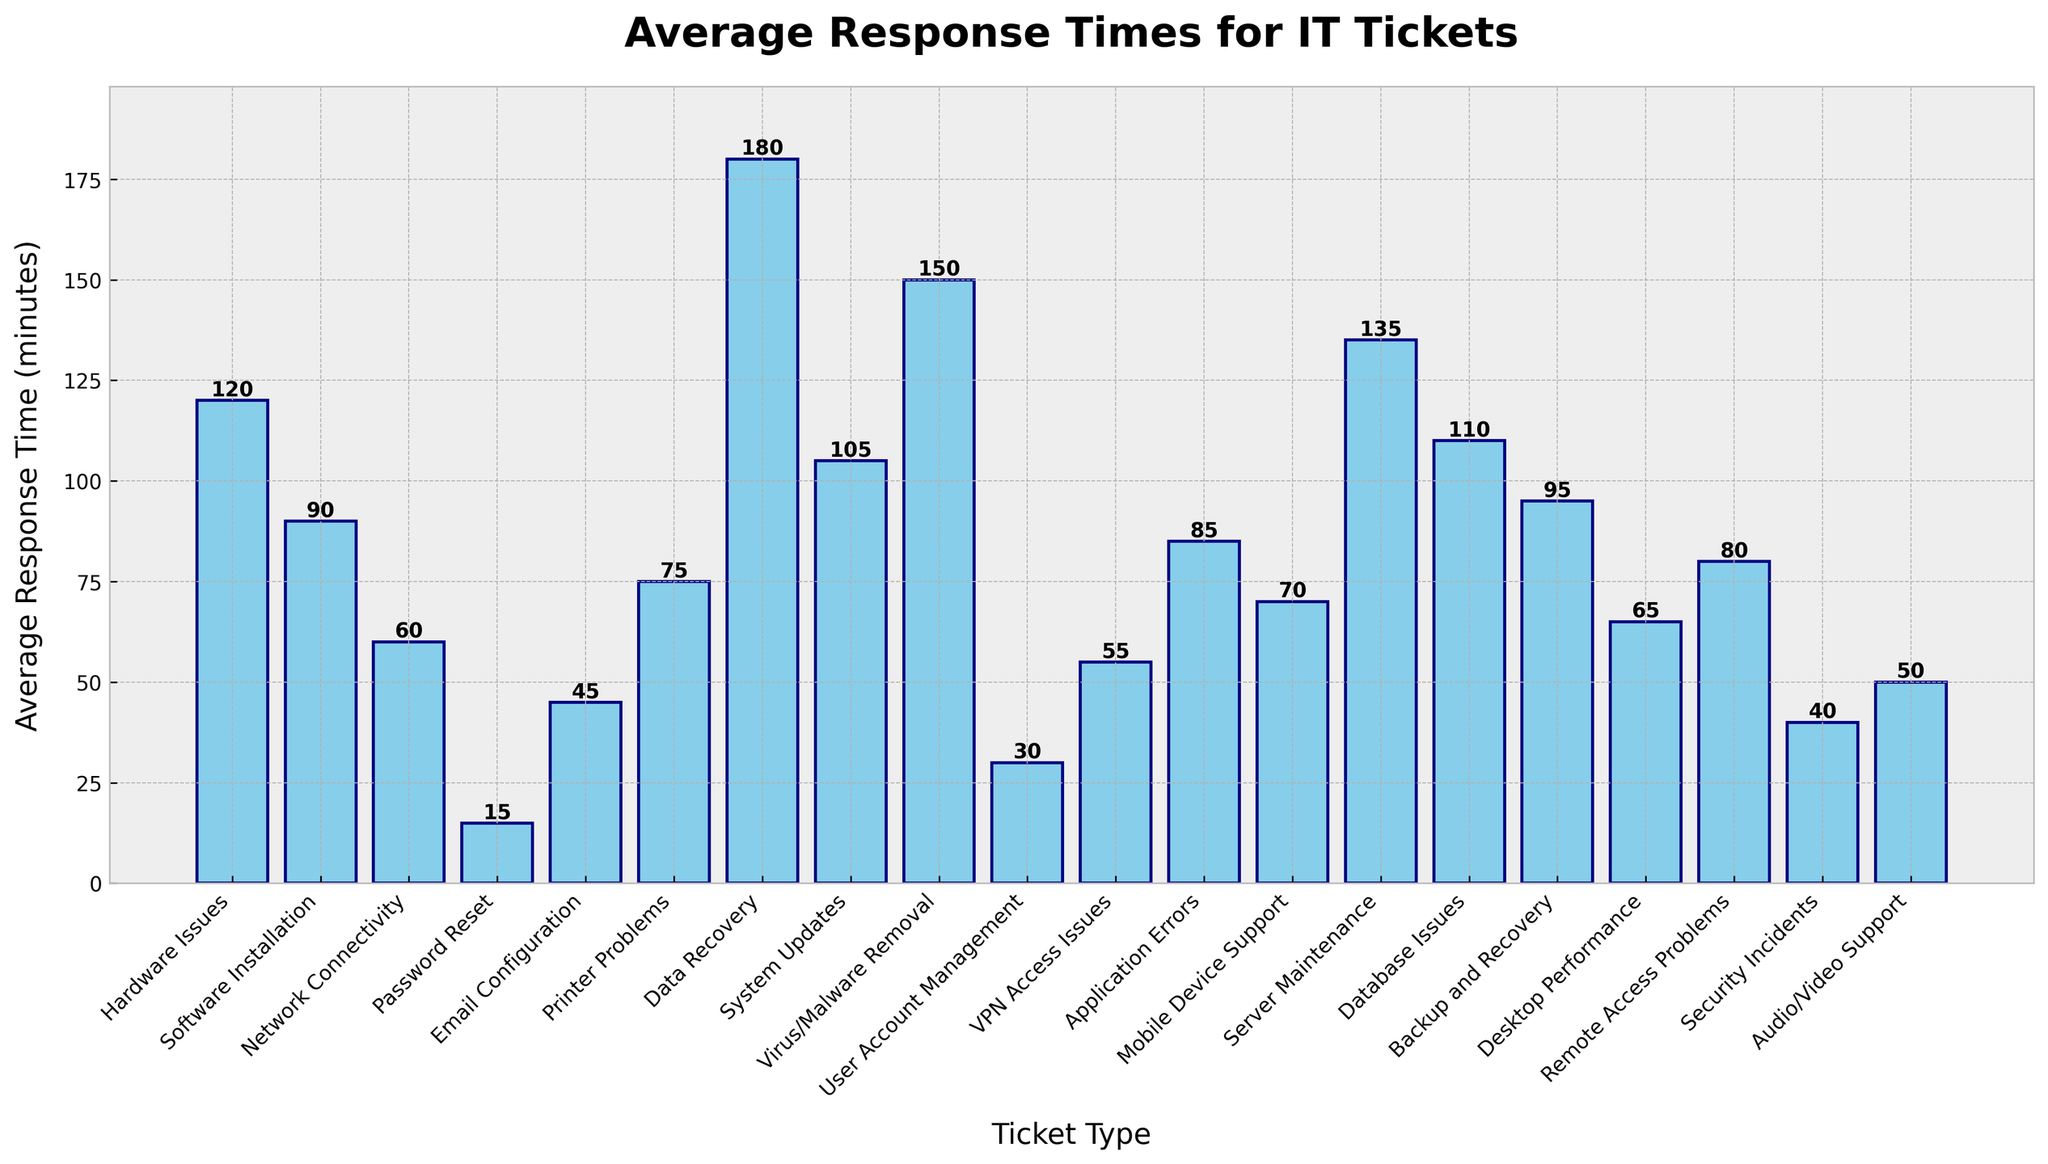Which ticket type has the longest average response time? The bar for 'Data Recovery' is the highest among all types shown on the bar chart.
Answer: Data Recovery Which ticket type has the shortest average response time? The bar for 'Password Reset' is the shortest among all types shown on the bar chart.
Answer: Password Reset How much longer is the average response time for 'Virus/Malware Removal' compared to 'Email Configuration'? 'Virus/Malware Removal' has an average response time of 150 minutes, and 'Email Configuration' has 45 minutes. The difference is 150 - 45 = 105 minutes.
Answer: 105 minutes What's the average of the response times for 'Network Connectivity', 'Password Reset', and 'Email Configuration'? The response times are 60, 15, and 45 minutes respectively. The average is (60 + 15 + 45) / 3 = 120 / 3 = 40 minutes.
Answer: 40 minutes Arrange 'Server Maintenance', 'Database Issues', and 'System Updates' in descending order of their average response times. The average response times are 135, 110, and 105 minutes respectively. Arranging them in descending order gives: 135, 110, 105.
Answer: Server Maintenance, Database Issues, System Updates Which ticket type has an average response time closest to 'Desktop Performance'? 'Desktop Performance' has an average response time of 65 minutes. 'Remote Access Problems' has a response time of 80 minutes, and 'VPN Access Issues' has a response time of 55 minutes. The closest is 'VPN Access Issues' which is 10 minutes away from 65 compared to 'Remote Access Problems' which is 15 minutes away.
Answer: VPN Access Issues How much shorter is the average response time for 'Audio/Video Support' compared to 'Application Errors'? 'Audio/Video Support' has an average response time of 50 minutes, and 'Application Errors' has 85 minutes. The difference is 85 - 50 = 35 minutes.
Answer: 35 minutes What is the combined average response time for 'Hardware Issues', 'Software Installation', and 'Network Connectivity'? The response times are 120, 90, and 60 minutes respectively. The combined average response time is (120 + 90 + 60) / 3 = 270 / 3 = 90 minutes.
Answer: 90 minutes 